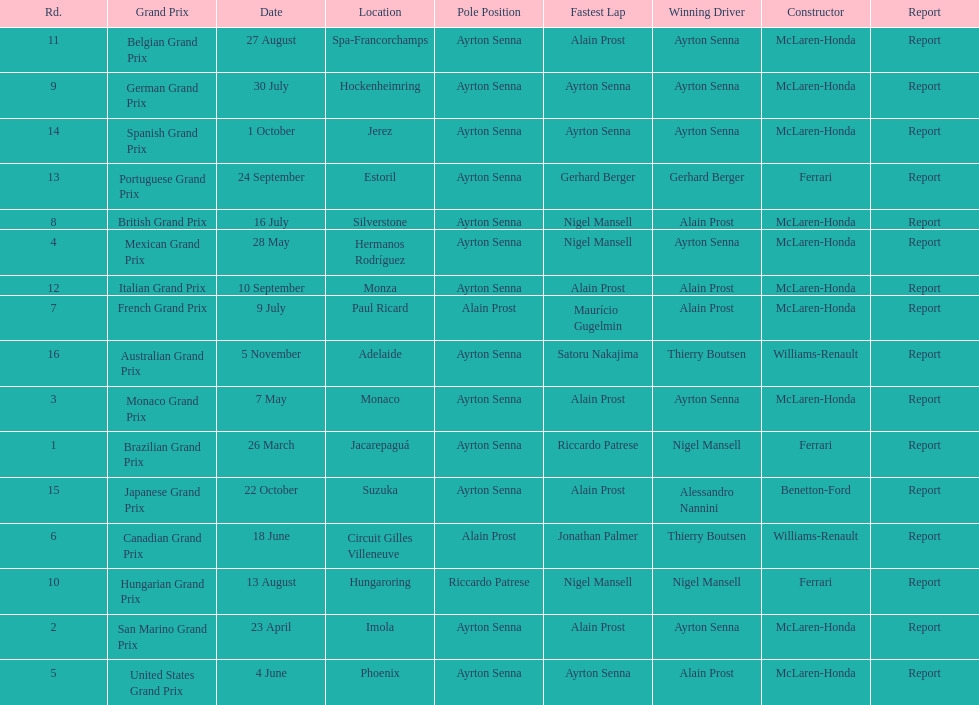What was the only grand prix to be won by benneton-ford? Japanese Grand Prix. 